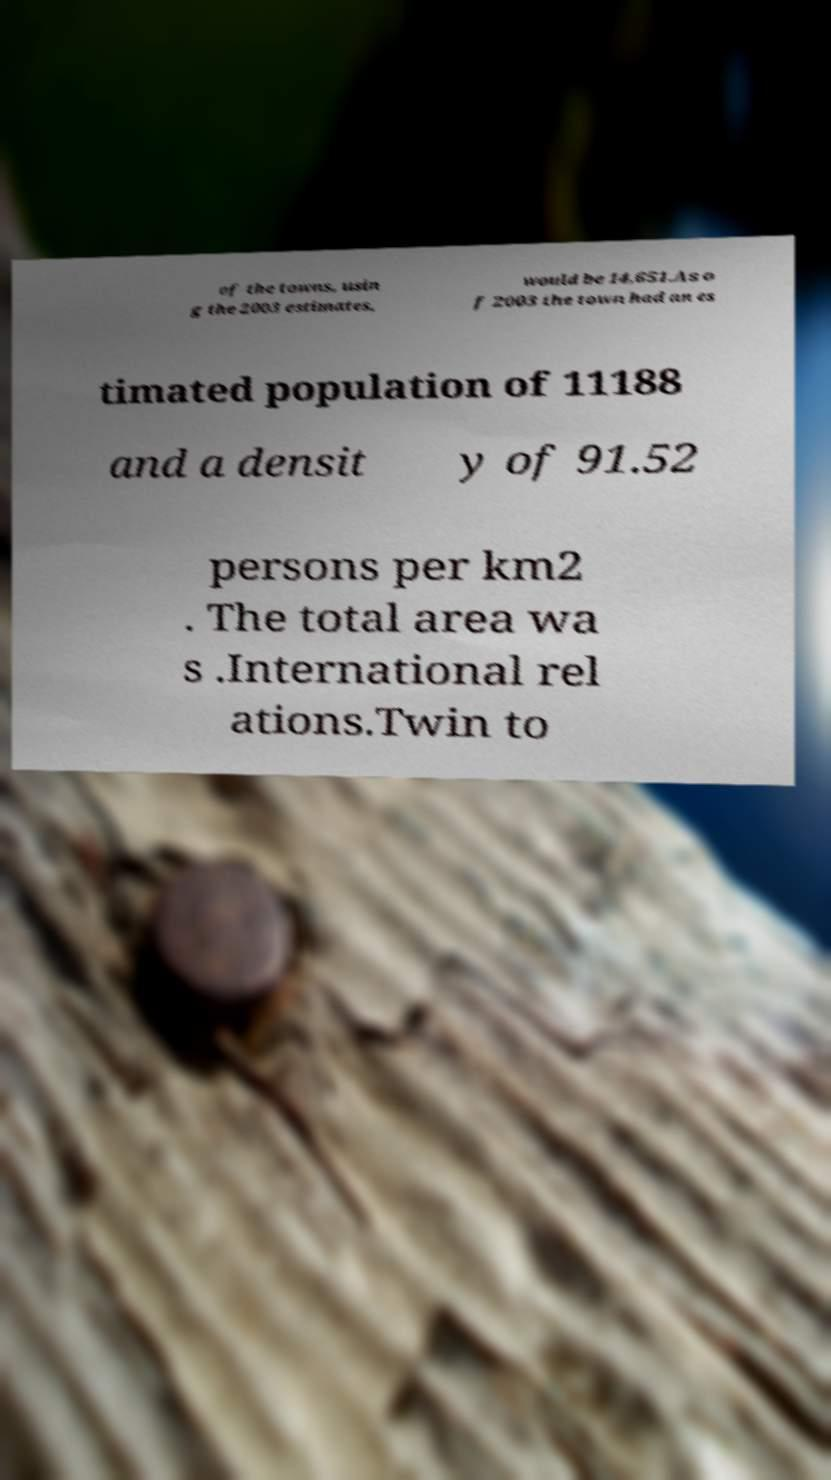Please read and relay the text visible in this image. What does it say? of the towns, usin g the 2003 estimates, would be 14,651.As o f 2003 the town had an es timated population of 11188 and a densit y of 91.52 persons per km2 . The total area wa s .International rel ations.Twin to 